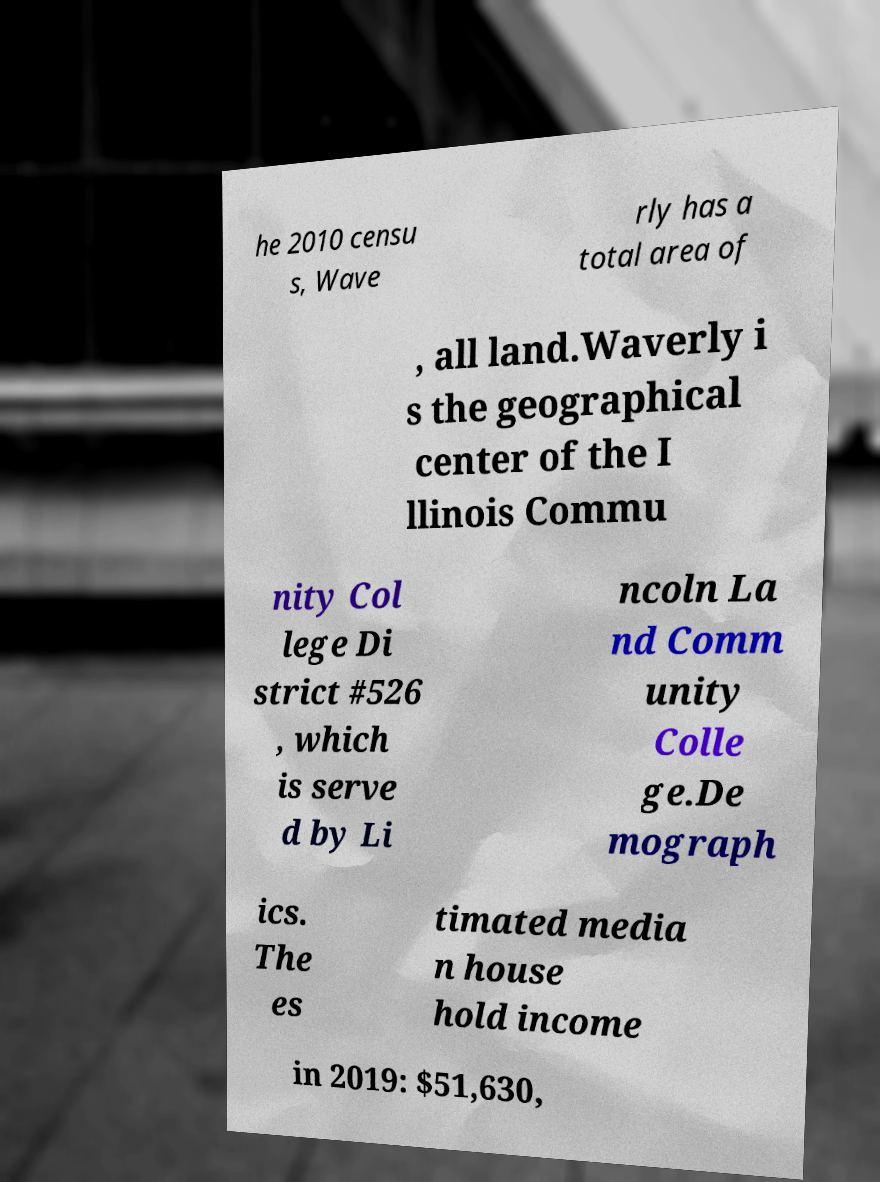Please identify and transcribe the text found in this image. he 2010 censu s, Wave rly has a total area of , all land.Waverly i s the geographical center of the I llinois Commu nity Col lege Di strict #526 , which is serve d by Li ncoln La nd Comm unity Colle ge.De mograph ics. The es timated media n house hold income in 2019: $51,630, 